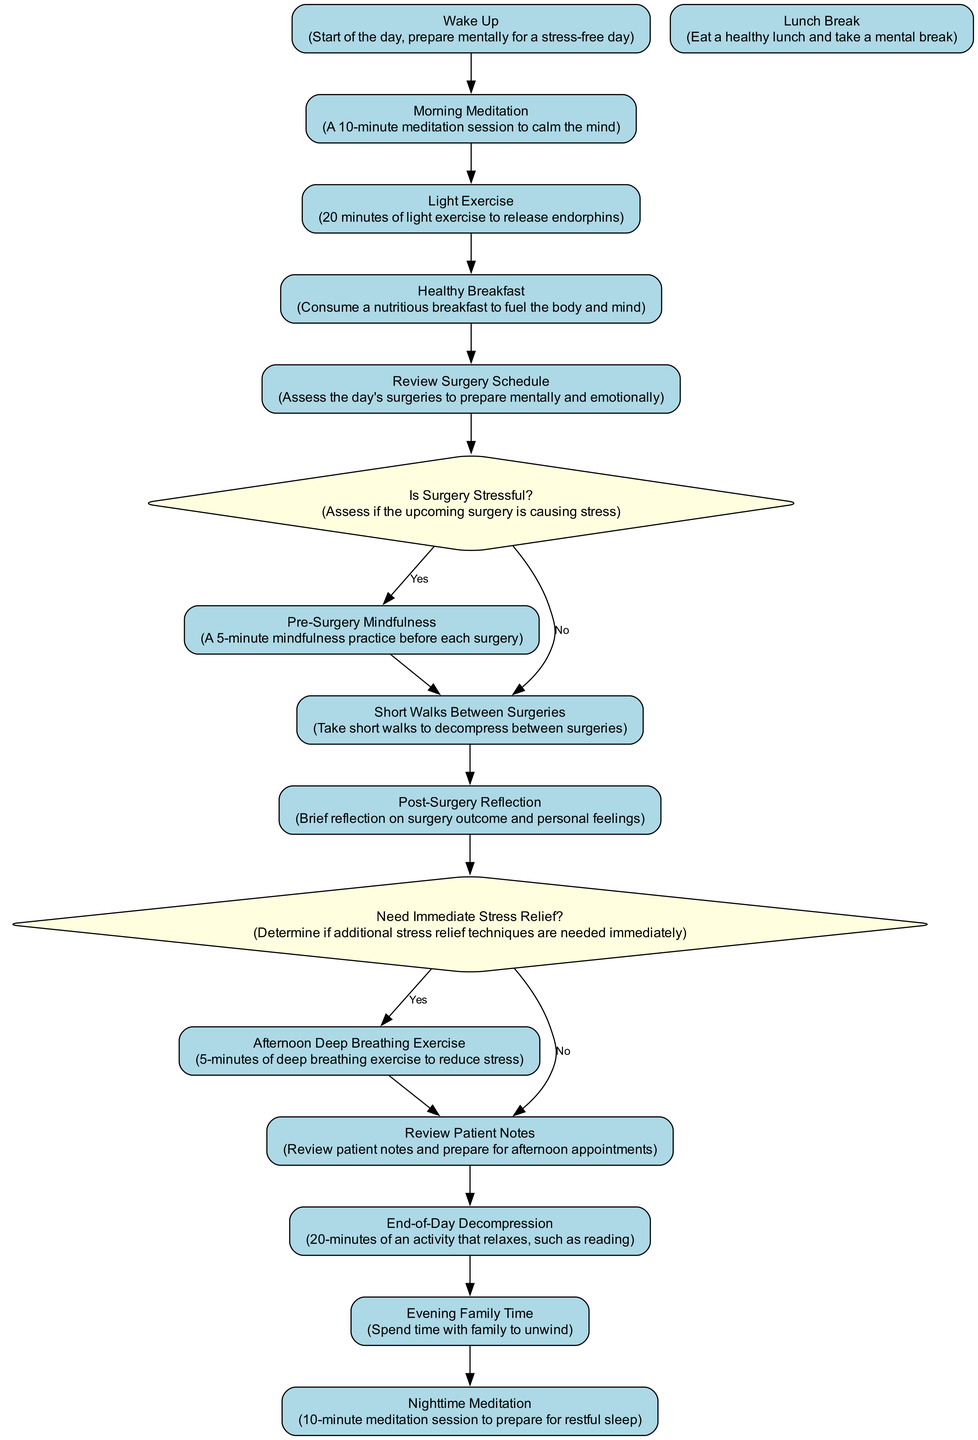What is the first activity listed in the diagram? The diagram starts with the "Wake Up" activity, which is the initial step and acts as the beginning of the daily stress management routine.
Answer: Wake Up How many decision points are there in the diagram? The diagram contains 2 decision points: "Is Surgery Stressful?" and "Need Immediate Stress Relief?" Thus, the count of decision points is two.
Answer: 2 What activity follows "Review Surgery Schedule" when surgery is stressful? When "Review Surgery Schedule" leads to the decision point "Is Surgery Stressful?" and the answer is "Yes," the next activity is "Pre-Surgery Mindfulness."
Answer: Pre-Surgery Mindfulness What is the last activity performed in the day? The final activity listed in the diagram is "Nighttime Meditation," marking the end of the daily routine for stress management.
Answer: Nighttime Meditation How many activities are there between "Wake Up" and "Review Patient Notes"? The sequence from "Wake Up" to "Review Patient Notes" includes five activities: "Wake Up," "Morning Meditation," "Light Exercise," "Healthy Breakfast," and "Review Surgery Schedule," totaling five activities.
Answer: 5 What occurs if immediate stress relief is needed after post-surgery reflection? If immediate stress relief is required, the next step after "Post-Surgery Reflection" is "Afternoon Deep Breathing Exercise," providing a quick stress-relief technique.
Answer: Afternoon Deep Breathing Exercise Which activity directly precedes "End-of-Day Decompression"? The activity that comes right before "End-of-Day Decompression" in the diagram is "Review Patient Notes," which is the precursor activity leading to decompression at the day’s end.
Answer: Review Patient Notes What decision point comes after "Post-Surgery Reflection"? Following "Post-Surgery Reflection," the diagram presents the decision point "Need Immediate Stress Relief?" which evaluates the necessity of stress relief techniques.
Answer: Need Immediate Stress Relief 